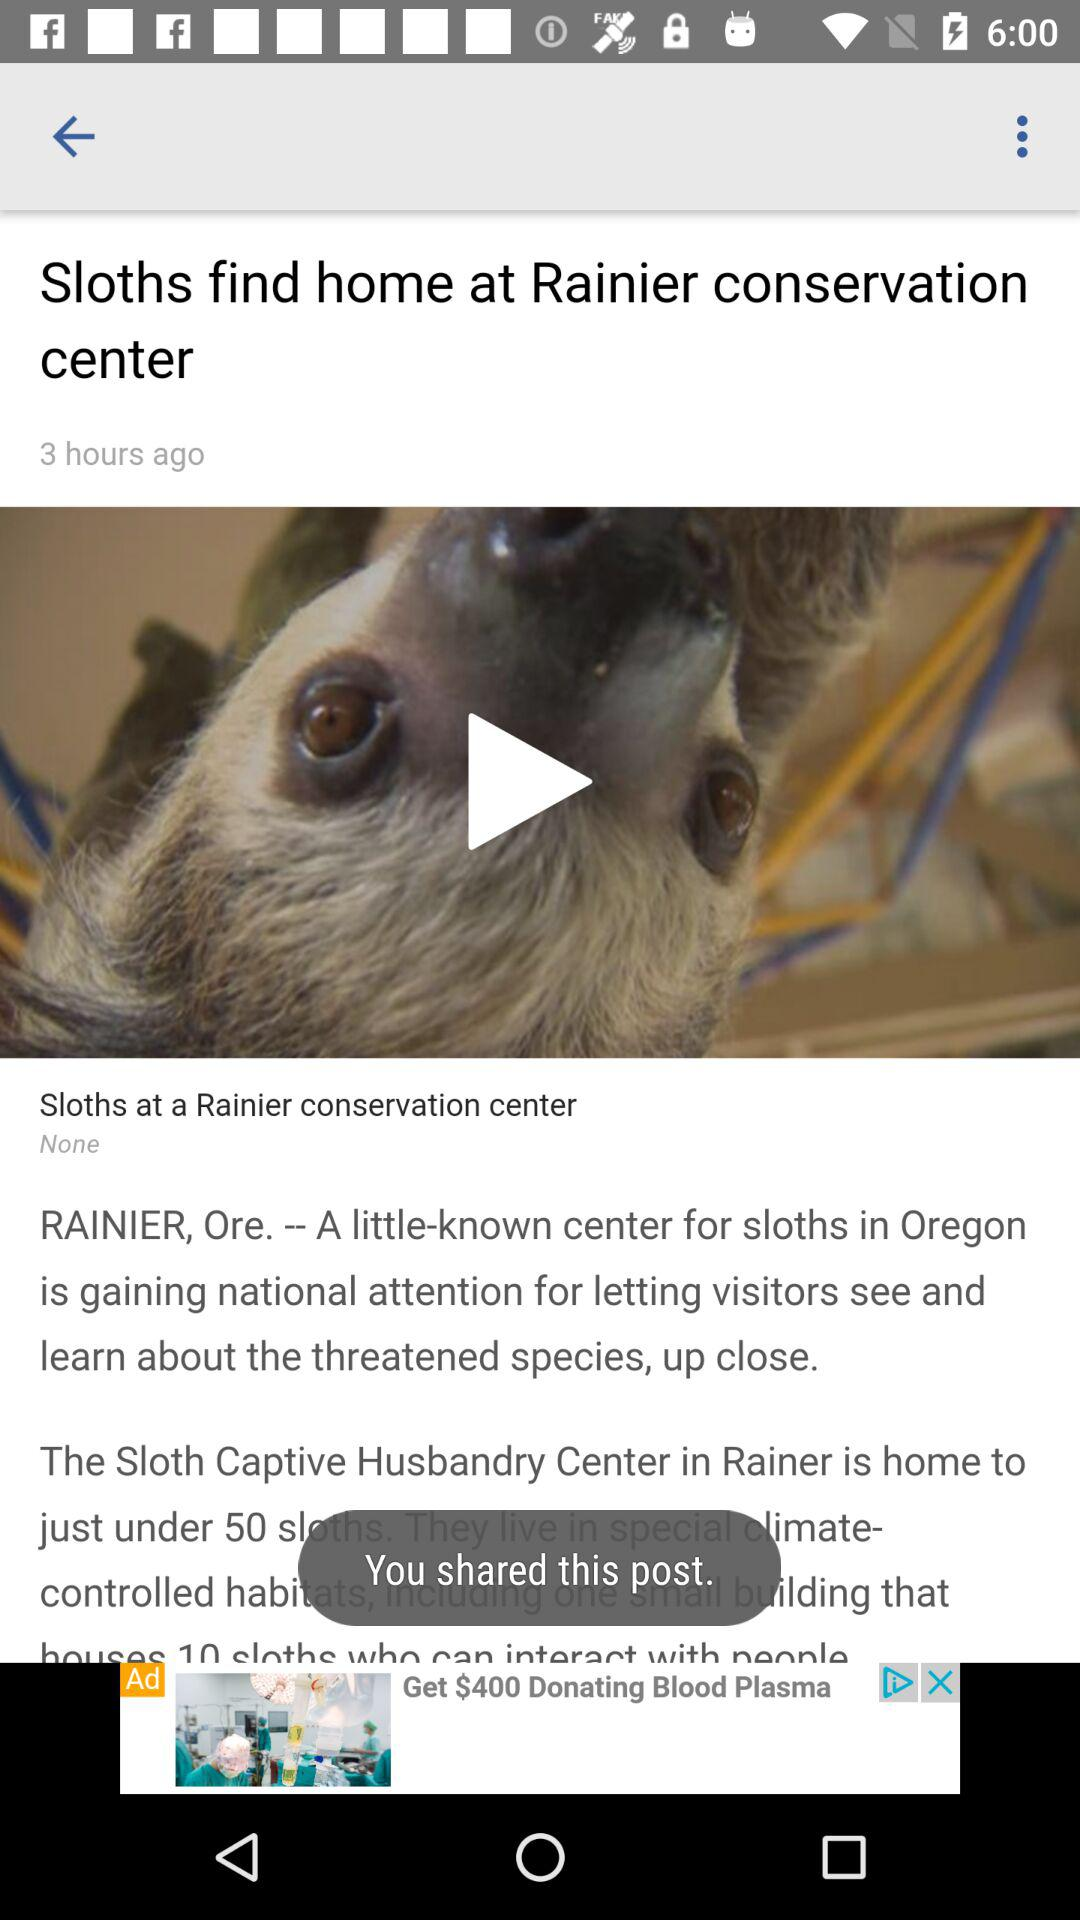What is the location of the center? The location is Rainier, Oregon. 